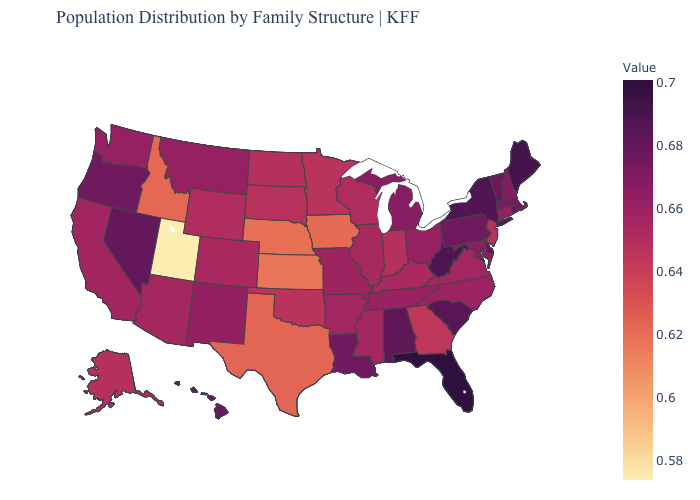Does Arizona have the highest value in the USA?
Quick response, please. No. Among the states that border Ohio , does West Virginia have the highest value?
Be succinct. Yes. Among the states that border Virginia , which have the lowest value?
Write a very short answer. Kentucky. Does North Dakota have a higher value than Vermont?
Short answer required. No. Does Michigan have the lowest value in the MidWest?
Write a very short answer. No. Which states have the lowest value in the Northeast?
Answer briefly. New Jersey. 